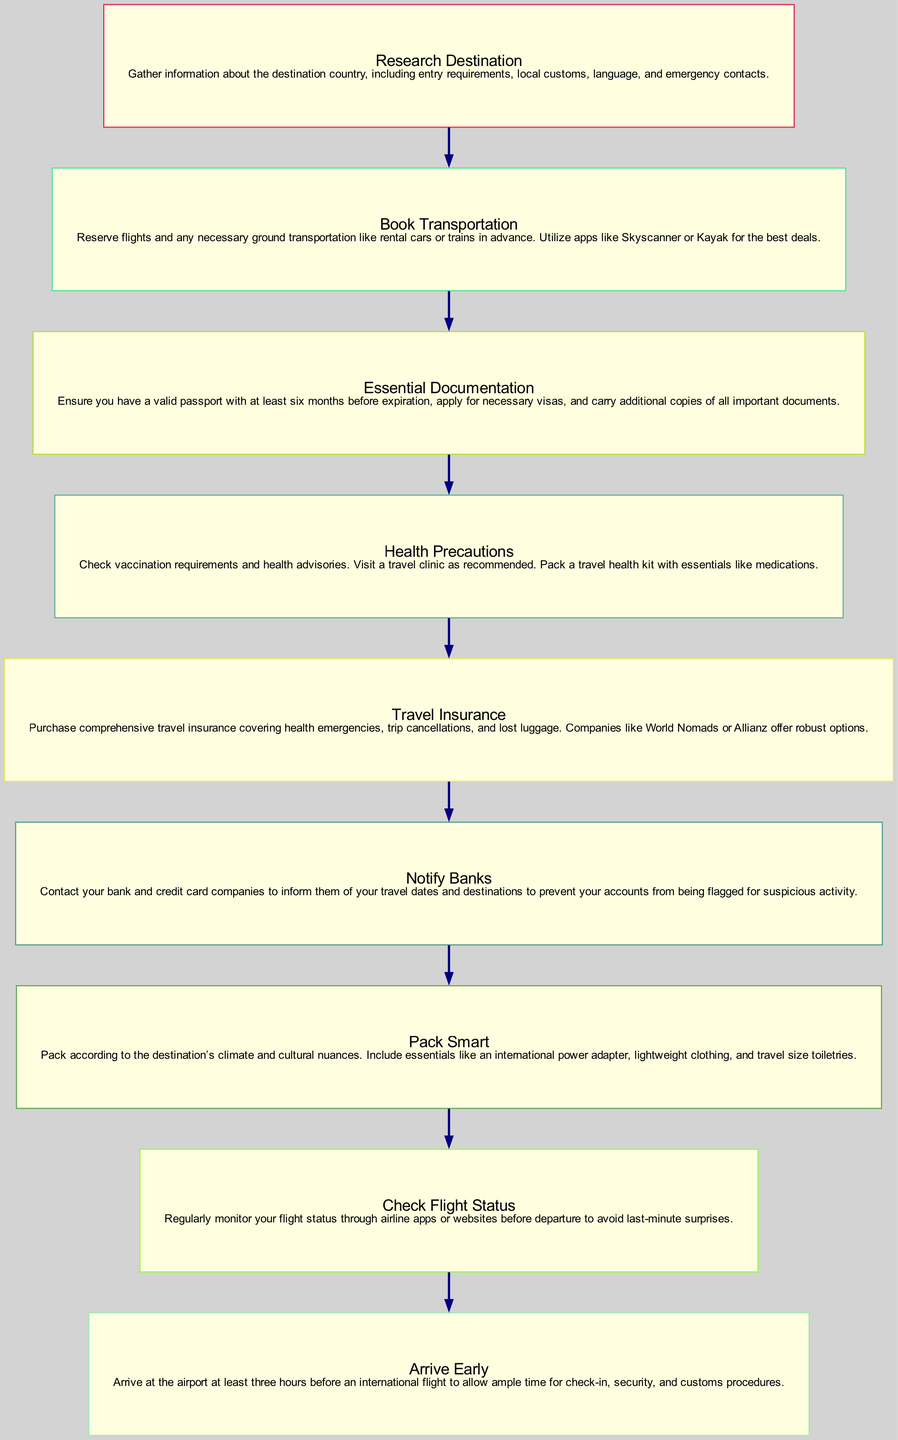What is the first step in the flow chart? The flow chart starts with the node labeled "Research Destination." This indicates the initial action to be taken before proceeding with other travel preparations.
Answer: Research Destination How many total steps are there in the diagram? By counting the individual nodes listed in the flow chart, there are a total of nine steps outlined in the instruction.
Answer: 9 What step follows "Notify Banks"? "Pack Smart" is the immediate next step after "Notify Banks," showing a clear progression of actions in preparing for travel.
Answer: Pack Smart Which step involves purchasing travel insurance? The specific step that discusses this action is "Travel Insurance," which directly mentions the need for purchasing comprehensive insurance for various travel-related issues.
Answer: Travel Insurance What is the last step in the diagram? The final step indicated in the flow chart is "Arrive Early," which emphasizes the importance of timely arrival at the airport for international flights.
Answer: Arrive Early How does "Health Precautions" relate to "Essential Documentation"? "Health Precautions" ensures that travelers are informed about health-related requirements, while "Essential Documentation" focuses on the necessary travel documents. Both steps are critical for ensuring safe travel, but they cover different aspects; thus, they are connected conceptually through overall travel readiness.
Answer: Conceptual relationship What should you check before departure, according to the chart? The step instructs to "Check Flight Status," which is crucial for confirming the details of the departure flight to avoid any last-minute issues.
Answer: Check Flight Status Name one app suggested for booking transportation. "Skyscanner" is mentioned as an app to use for reserving flights and ground transportation, making the travel booking process easier and more efficient.
Answer: Skyscanner How early should you arrive at the airport for international flights? The instruction specifies arriving at least "three hours before" the flight, which accounts for check-in and security procedures.
Answer: Three hours 